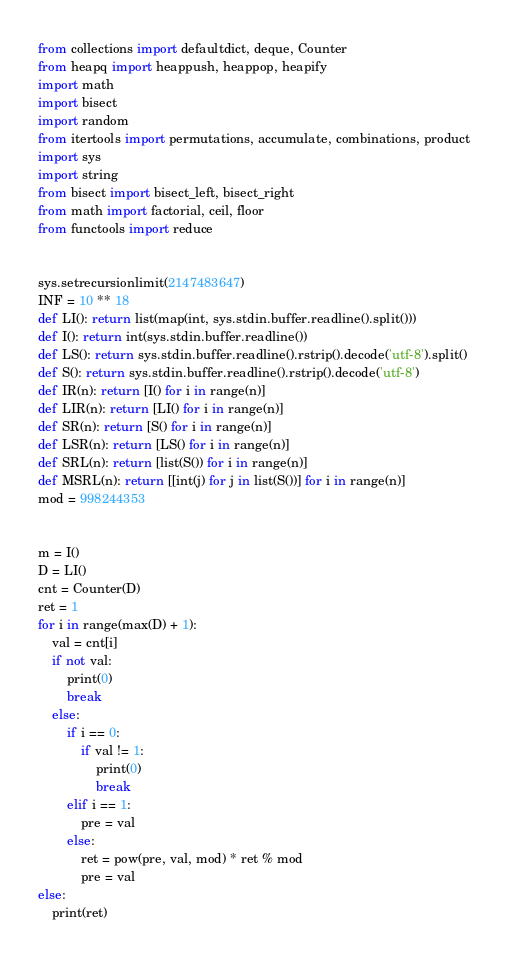<code> <loc_0><loc_0><loc_500><loc_500><_Python_>from collections import defaultdict, deque, Counter
from heapq import heappush, heappop, heapify
import math
import bisect
import random
from itertools import permutations, accumulate, combinations, product
import sys
import string
from bisect import bisect_left, bisect_right
from math import factorial, ceil, floor
from functools import reduce


sys.setrecursionlimit(2147483647)
INF = 10 ** 18
def LI(): return list(map(int, sys.stdin.buffer.readline().split()))
def I(): return int(sys.stdin.buffer.readline())
def LS(): return sys.stdin.buffer.readline().rstrip().decode('utf-8').split()
def S(): return sys.stdin.buffer.readline().rstrip().decode('utf-8')
def IR(n): return [I() for i in range(n)]
def LIR(n): return [LI() for i in range(n)]
def SR(n): return [S() for i in range(n)]
def LSR(n): return [LS() for i in range(n)]
def SRL(n): return [list(S()) for i in range(n)]
def MSRL(n): return [[int(j) for j in list(S())] for i in range(n)]
mod = 998244353


m = I()
D = LI()
cnt = Counter(D)
ret = 1
for i in range(max(D) + 1):
    val = cnt[i]
    if not val:
        print(0)
        break
    else:
        if i == 0:
            if val != 1:
                print(0)
                break
        elif i == 1:
            pre = val
        else:
            ret = pow(pre, val, mod) * ret % mod
            pre = val
else:
    print(ret)



</code> 